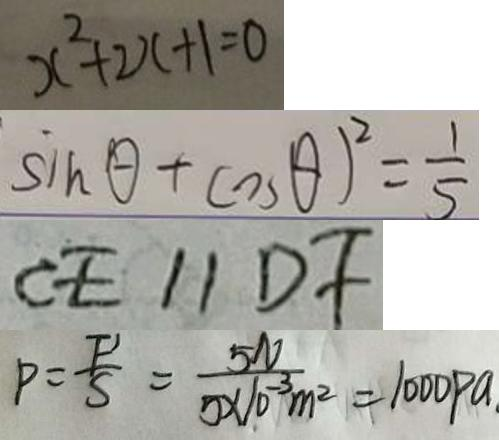<formula> <loc_0><loc_0><loc_500><loc_500>x ^ { 2 } + 2 x + 1 = 0 
 \sin \theta + \cos \theta ) ^ { 2 } = \frac { 1 } { 5 } 
 C E / / D F 
 P = \frac { F ^ { \prime } } { S } = \frac { 5 N } { 5 \times 1 0 ^ { - 3 } m ^ { 2 } } = 1 0 0 0 P a</formula> 